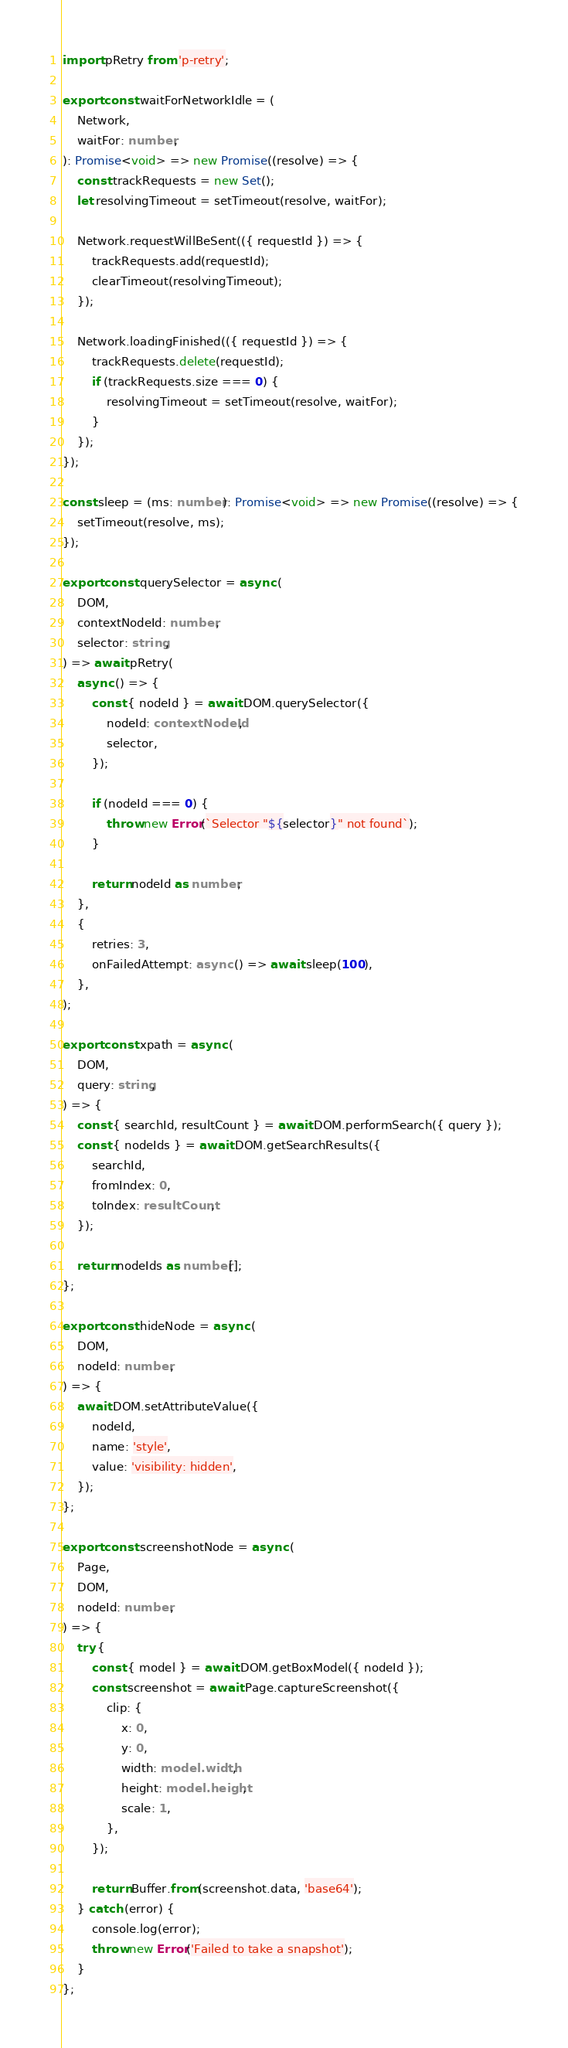Convert code to text. <code><loc_0><loc_0><loc_500><loc_500><_TypeScript_>import pRetry from 'p-retry';

export const waitForNetworkIdle = (
	Network,
	waitFor: number,
): Promise<void> => new Promise((resolve) => {
	const trackRequests = new Set();
	let resolvingTimeout = setTimeout(resolve, waitFor);

	Network.requestWillBeSent(({ requestId }) => {
		trackRequests.add(requestId);
		clearTimeout(resolvingTimeout);
	});

	Network.loadingFinished(({ requestId }) => {
		trackRequests.delete(requestId);
		if (trackRequests.size === 0) {
			resolvingTimeout = setTimeout(resolve, waitFor);
		}
	});
});

const sleep = (ms: number): Promise<void> => new Promise((resolve) => {
	setTimeout(resolve, ms);
});

export const querySelector = async (
	DOM,
	contextNodeId: number,
	selector: string,
) => await pRetry(
	async () => {
		const { nodeId } = await DOM.querySelector({
			nodeId: contextNodeId,
			selector,
		});

		if (nodeId === 0) {
			throw new Error(`Selector "${selector}" not found`);
		}

		return nodeId as number;
	},
	{
		retries: 3,
		onFailedAttempt: async () => await sleep(100),
	},
);

export const xpath = async (
	DOM,
	query: string,
) => {
	const { searchId, resultCount } = await DOM.performSearch({ query });
	const { nodeIds } = await DOM.getSearchResults({
		searchId,
		fromIndex: 0,
		toIndex: resultCount,
	});

	return nodeIds as number[];
};

export const hideNode = async (
	DOM,
	nodeId: number,
) => {
	await DOM.setAttributeValue({
		nodeId,
		name: 'style',
		value: 'visibility: hidden',
	});
};

export const screenshotNode = async (
	Page,
	DOM,
	nodeId: number,
) => {
	try {
		const { model } = await DOM.getBoxModel({ nodeId });
		const screenshot = await Page.captureScreenshot({
			clip: {
				x: 0,
				y: 0,
				width: model.width,
				height: model.height,
				scale: 1,
			},
		});

		return Buffer.from(screenshot.data, 'base64');
	} catch (error) {
		console.log(error);
		throw new Error('Failed to take a snapshot');
	}
};
</code> 